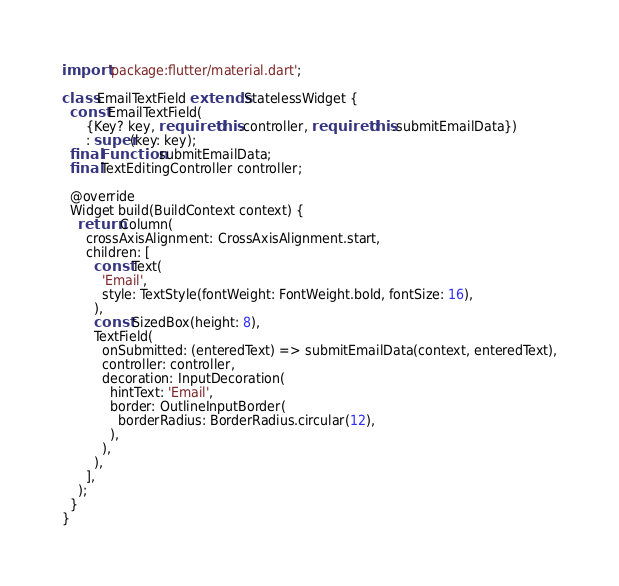Convert code to text. <code><loc_0><loc_0><loc_500><loc_500><_Dart_>import 'package:flutter/material.dart';

class EmailTextField extends StatelessWidget {
  const EmailTextField(
      {Key? key, required this.controller, required this.submitEmailData})
      : super(key: key);
  final Function submitEmailData;
  final TextEditingController controller;

  @override
  Widget build(BuildContext context) {
    return Column(
      crossAxisAlignment: CrossAxisAlignment.start,
      children: [
        const Text(
          'Email',
          style: TextStyle(fontWeight: FontWeight.bold, fontSize: 16),
        ),
        const SizedBox(height: 8),
        TextField(
          onSubmitted: (enteredText) => submitEmailData(context, enteredText),
          controller: controller,
          decoration: InputDecoration(
            hintText: 'Email',
            border: OutlineInputBorder(
              borderRadius: BorderRadius.circular(12),
            ),
          ),
        ),
      ],
    );
  }
}
</code> 